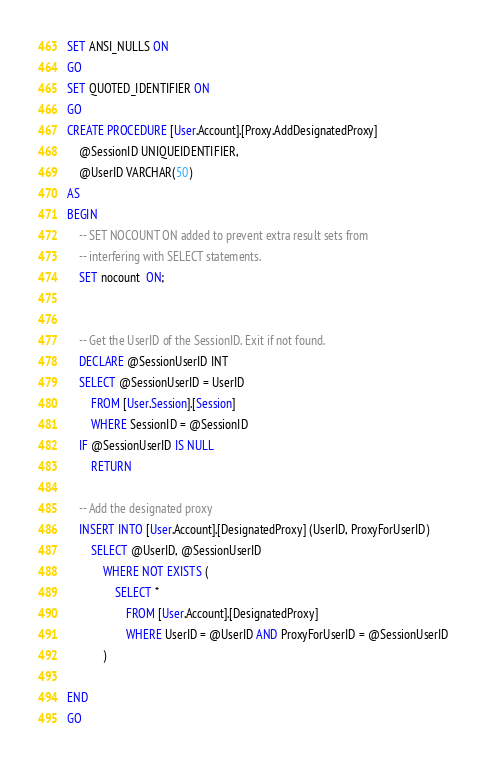<code> <loc_0><loc_0><loc_500><loc_500><_SQL_>SET ANSI_NULLS ON
GO
SET QUOTED_IDENTIFIER ON
GO
CREATE PROCEDURE [User.Account].[Proxy.AddDesignatedProxy]
	@SessionID UNIQUEIDENTIFIER,
	@UserID VARCHAR(50)
AS
BEGIN
	-- SET NOCOUNT ON added to prevent extra result sets from
	-- interfering with SELECT statements.
	SET nocount  ON;


	-- Get the UserID of the SessionID. Exit if not found.
	DECLARE @SessionUserID INT
	SELECT @SessionUserID = UserID
		FROM [User.Session].[Session]
		WHERE SessionID = @SessionID
	IF @SessionUserID IS NULL
		RETURN
	
	-- Add the designated proxy
	INSERT INTO [User.Account].[DesignatedProxy] (UserID, ProxyForUserID)
		SELECT @UserID, @SessionUserID
			WHERE NOT EXISTS (
				SELECT *
					FROM [User.Account].[DesignatedProxy]
					WHERE UserID = @UserID AND ProxyForUserID = @SessionUserID
			)

END
GO
</code> 